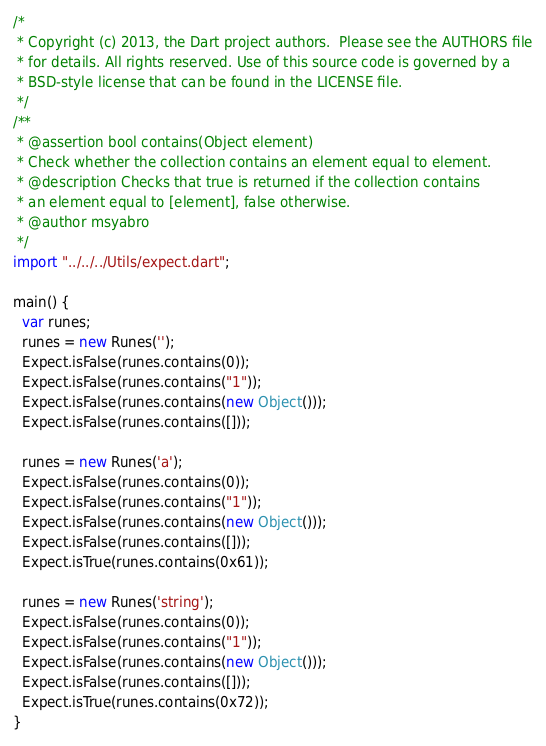<code> <loc_0><loc_0><loc_500><loc_500><_Dart_>/*
 * Copyright (c) 2013, the Dart project authors.  Please see the AUTHORS file
 * for details. All rights reserved. Use of this source code is governed by a
 * BSD-style license that can be found in the LICENSE file.
 */
/**
 * @assertion bool contains(Object element)
 * Check whether the collection contains an element equal to element.
 * @description Checks that true is returned if the collection contains
 * an element equal to [element], false otherwise.
 * @author msyabro
 */
import "../../../Utils/expect.dart";

main() {
  var runes;
  runes = new Runes('');
  Expect.isFalse(runes.contains(0));
  Expect.isFalse(runes.contains("1"));
  Expect.isFalse(runes.contains(new Object()));
  Expect.isFalse(runes.contains([]));

  runes = new Runes('a');
  Expect.isFalse(runes.contains(0));
  Expect.isFalse(runes.contains("1"));
  Expect.isFalse(runes.contains(new Object()));
  Expect.isFalse(runes.contains([]));
  Expect.isTrue(runes.contains(0x61));

  runes = new Runes('string');
  Expect.isFalse(runes.contains(0));
  Expect.isFalse(runes.contains("1"));
  Expect.isFalse(runes.contains(new Object()));
  Expect.isFalse(runes.contains([]));
  Expect.isTrue(runes.contains(0x72));
}
</code> 